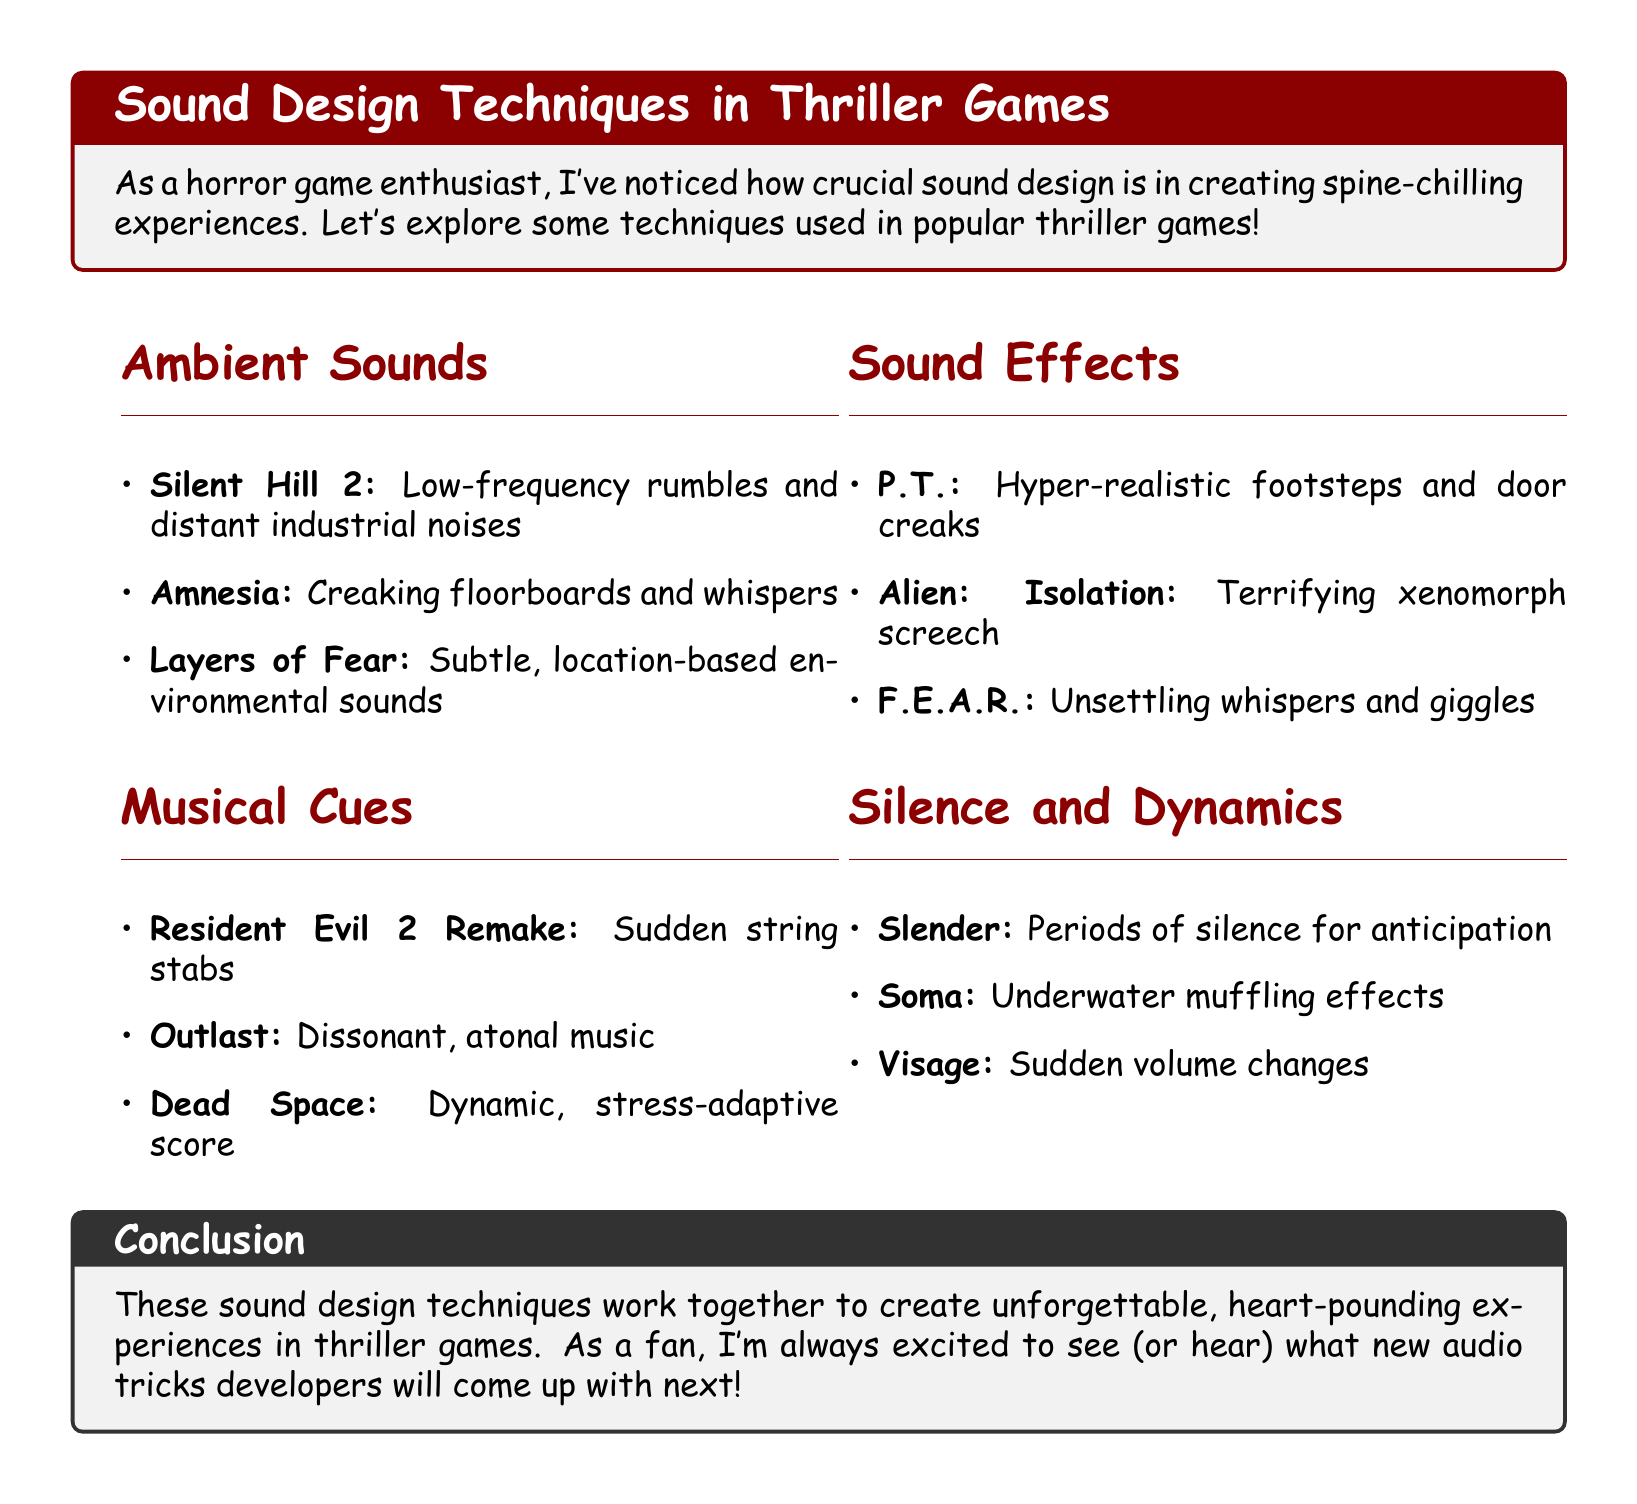What game uses low-frequency rumbles? Silent Hill 2 is mentioned as using low-frequency rumbles to create unease.
Answer: Silent Hill 2 What type of music does Outlast use? Outlast is noted for implementing dissonant, atonal music to create a sense of dread.
Answer: Dissonant, atonal music Which game features a terrifying xenomorph screech? Alien: Isolation is described as featuring a terrifying xenomorph screech that signals immediate danger.
Answer: Alien: Isolation What is a sound design technique used in Soma? Soma employs underwater muffling effects to create a sense of isolation.
Answer: Underwater muffling effects How do periods of silence function in Slender: The Eight Pages? Silence is used in Slender: The Eight Pages to build anticipation.
Answer: Build anticipation What is the purpose of sudden string stabs in Resident Evil 2 Remake? Sudden string stabs in Resident Evil 2 Remake are used to startle players during intense moments.
Answer: Startle players What do unsettling whispers contribute to in F.E.A.R.? Unsettling whispers in F.E.A.R. create a paranormal atmosphere.
Answer: Paranormal atmosphere How does Dead Space adapt its score? Dead Space features a dynamic score that adapts to the player's stress level.
Answer: Adapts to the player's stress level What is the general topic of the document? The document discusses sound design techniques in thriller games and their impact on creating tension and atmosphere.
Answer: Sound design techniques in thriller games 